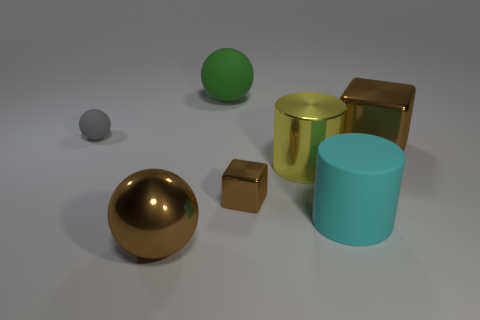Are there an equal number of large brown objects in front of the large cyan thing and large yellow metallic cylinders that are to the left of the big green ball?
Keep it short and to the point. No. How many rubber cylinders have the same color as the tiny block?
Provide a succinct answer. 0. There is a big block that is the same color as the small metal object; what is its material?
Your answer should be compact. Metal. What number of shiny objects are either gray objects or spheres?
Make the answer very short. 1. There is a large brown shiny thing that is left of the big brown shiny block; does it have the same shape as the rubber object in front of the gray matte sphere?
Keep it short and to the point. No. What number of big brown metal blocks are right of the tiny gray matte thing?
Your answer should be very brief. 1. Is there a big yellow cylinder that has the same material as the large green sphere?
Ensure brevity in your answer.  No. There is a green object that is the same size as the metal sphere; what material is it?
Give a very brief answer. Rubber. Do the big brown cube and the green ball have the same material?
Your answer should be very brief. No. What number of things are either big brown spheres or small brown shiny objects?
Your response must be concise. 2. 